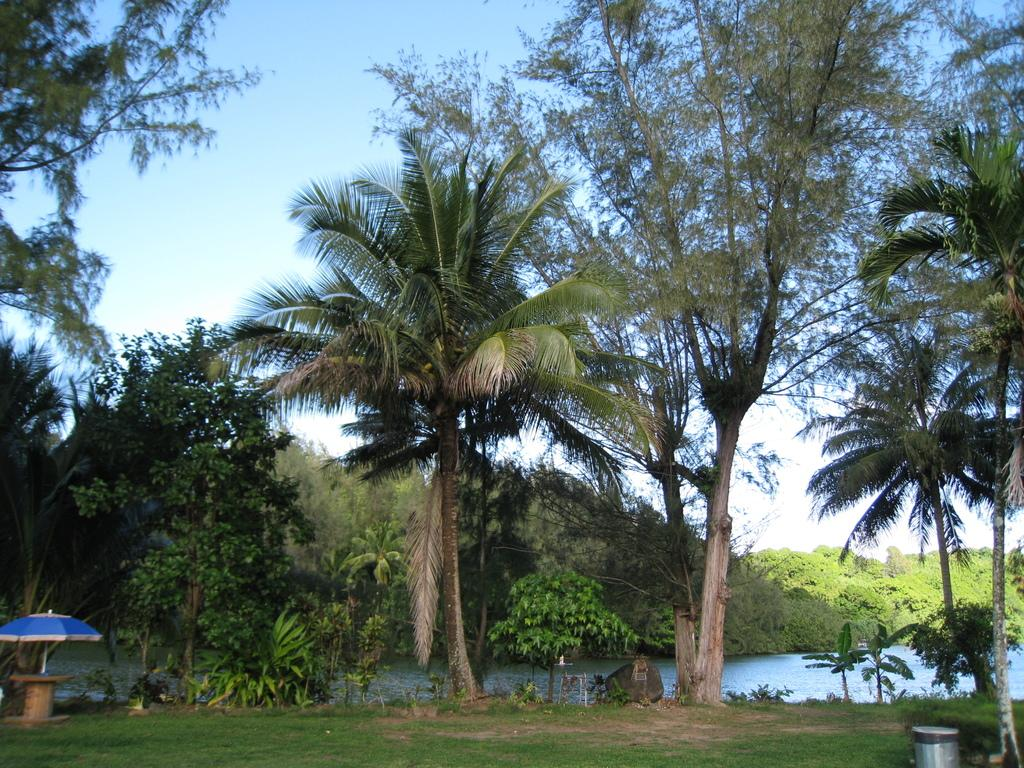What type of vegetation can be seen in the image? There is grass in the image. What else is present in the image besides grass? There is water, an umbrella, trees, some objects, and the sky is visible in the background. What might be used for shade in the image? The umbrella in the image might be used for shade. What is the natural setting visible in the image? The natural setting includes grass, water, and trees. What type of business is being managed by the person at the seashore in the image? There is no person or seashore present in the image, so it is not possible to answer that question. 